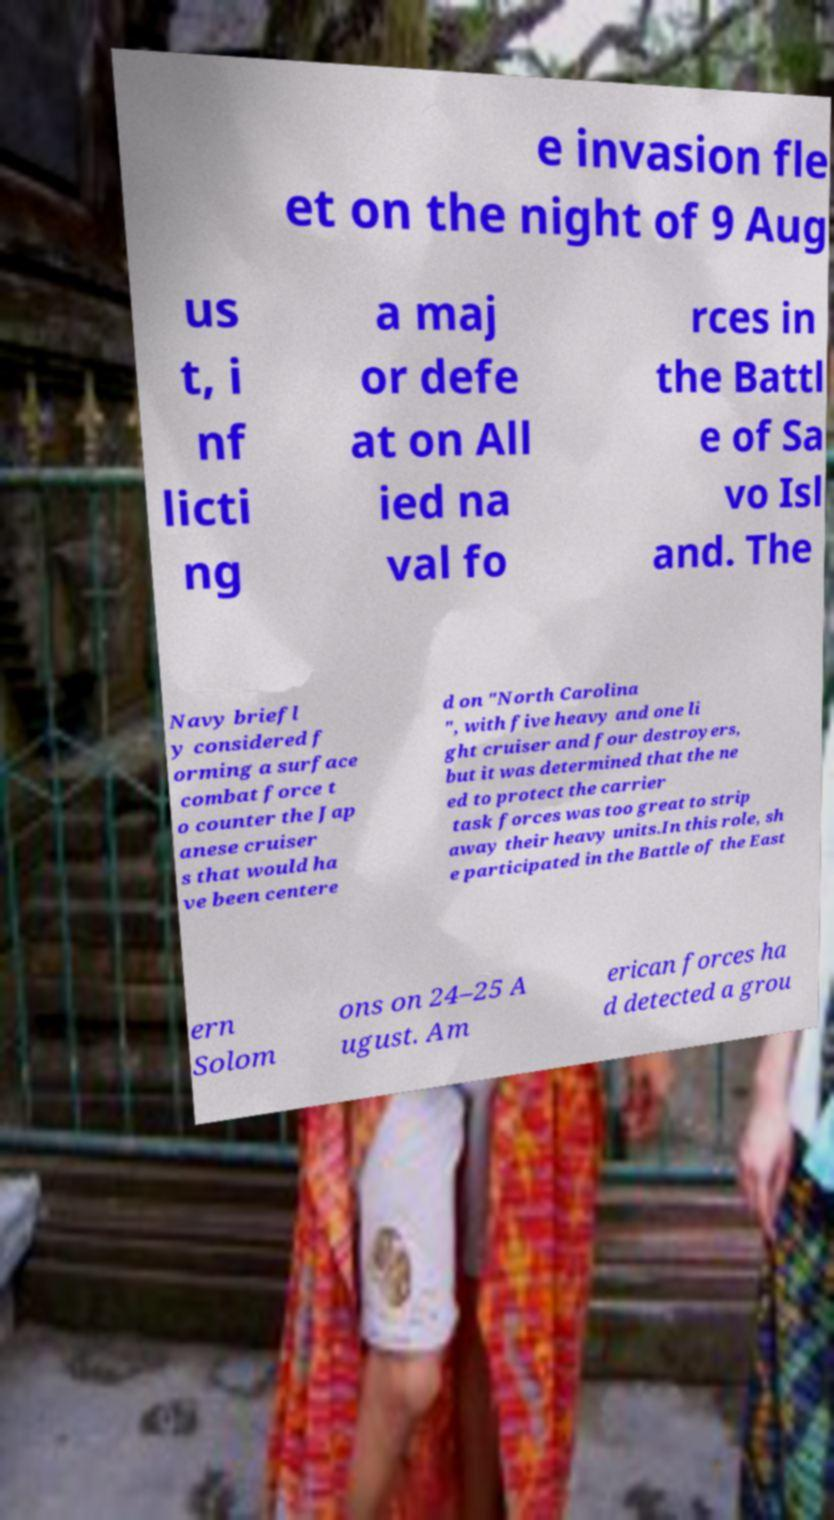Can you read and provide the text displayed in the image?This photo seems to have some interesting text. Can you extract and type it out for me? e invasion fle et on the night of 9 Aug us t, i nf licti ng a maj or defe at on All ied na val fo rces in the Battl e of Sa vo Isl and. The Navy briefl y considered f orming a surface combat force t o counter the Jap anese cruiser s that would ha ve been centere d on "North Carolina ", with five heavy and one li ght cruiser and four destroyers, but it was determined that the ne ed to protect the carrier task forces was too great to strip away their heavy units.In this role, sh e participated in the Battle of the East ern Solom ons on 24–25 A ugust. Am erican forces ha d detected a grou 